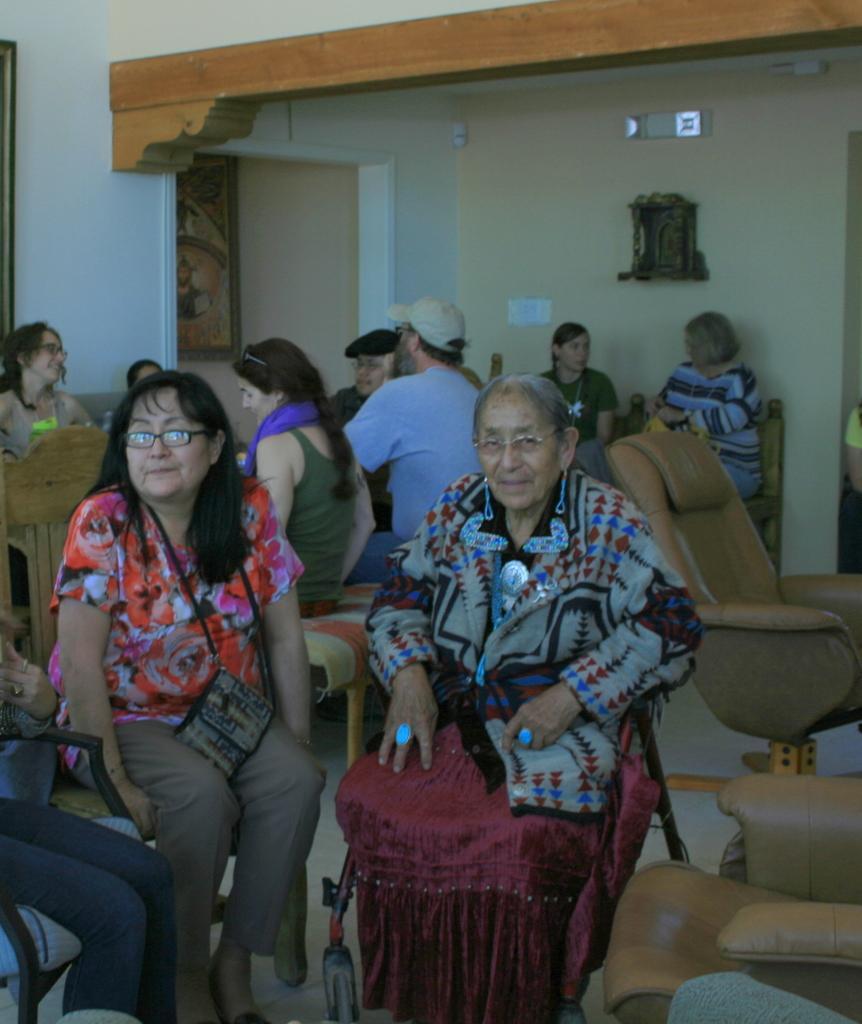Please provide a concise description of this image. In this image we can see a group of people sitting on the chairs placed on the floor. One woman is carrying a bag and wearing spectacles. In the background, we can see a group of chairs, photo frame on the wall and a person wearing blue shirt with a cap. 